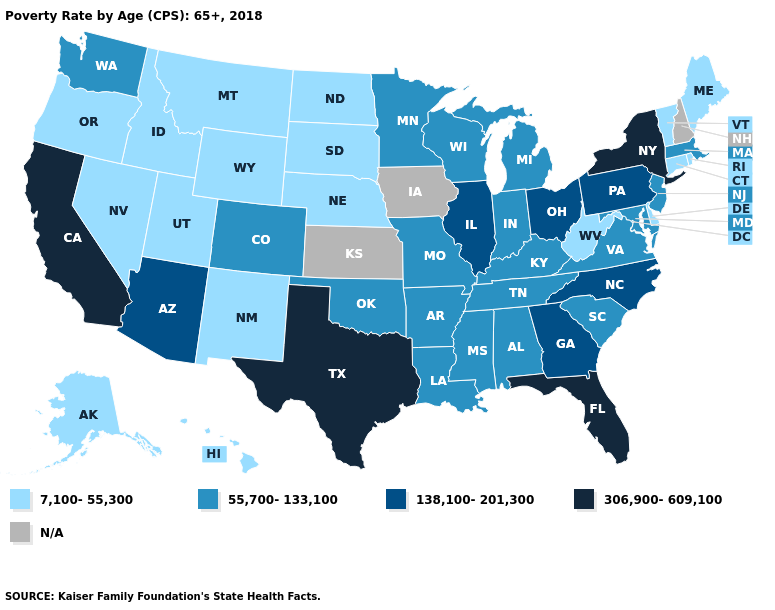What is the value of Washington?
Answer briefly. 55,700-133,100. Name the states that have a value in the range 306,900-609,100?
Give a very brief answer. California, Florida, New York, Texas. Name the states that have a value in the range N/A?
Be succinct. Iowa, Kansas, New Hampshire. Is the legend a continuous bar?
Answer briefly. No. What is the lowest value in the MidWest?
Write a very short answer. 7,100-55,300. What is the value of Maryland?
Answer briefly. 55,700-133,100. Name the states that have a value in the range 55,700-133,100?
Write a very short answer. Alabama, Arkansas, Colorado, Indiana, Kentucky, Louisiana, Maryland, Massachusetts, Michigan, Minnesota, Mississippi, Missouri, New Jersey, Oklahoma, South Carolina, Tennessee, Virginia, Washington, Wisconsin. Among the states that border Massachusetts , does New York have the highest value?
Write a very short answer. Yes. What is the value of Kansas?
Short answer required. N/A. What is the value of Nevada?
Write a very short answer. 7,100-55,300. Which states have the lowest value in the USA?
Quick response, please. Alaska, Connecticut, Delaware, Hawaii, Idaho, Maine, Montana, Nebraska, Nevada, New Mexico, North Dakota, Oregon, Rhode Island, South Dakota, Utah, Vermont, West Virginia, Wyoming. Does California have the highest value in the USA?
Answer briefly. Yes. Which states hav the highest value in the West?
Quick response, please. California. 